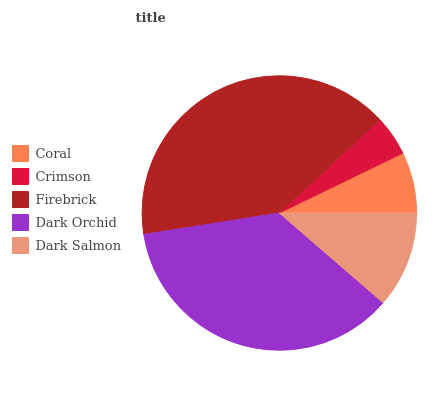Is Crimson the minimum?
Answer yes or no. Yes. Is Firebrick the maximum?
Answer yes or no. Yes. Is Firebrick the minimum?
Answer yes or no. No. Is Crimson the maximum?
Answer yes or no. No. Is Firebrick greater than Crimson?
Answer yes or no. Yes. Is Crimson less than Firebrick?
Answer yes or no. Yes. Is Crimson greater than Firebrick?
Answer yes or no. No. Is Firebrick less than Crimson?
Answer yes or no. No. Is Dark Salmon the high median?
Answer yes or no. Yes. Is Dark Salmon the low median?
Answer yes or no. Yes. Is Firebrick the high median?
Answer yes or no. No. Is Crimson the low median?
Answer yes or no. No. 